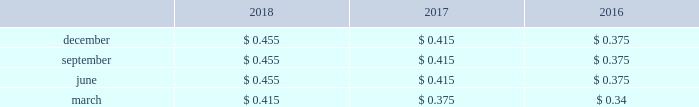Flows of the company 2019s subsidiaries , the receipt of dividends and repayments of indebtedness from the company 2019s subsidiaries , compliance with delaware corporate and other laws , compliance with the contractual provisions of debt and other agreements , and other factors .
The company 2019s dividend rate on its common stock is determined by the board of directors on a quarterly basis and takes into consideration , among other factors , current and possible future developments that may affect the company 2019s income and cash flows .
When dividends on common stock are declared , they are typically paid in march , june , september and december .
Historically , dividends have been paid quarterly to holders of record less than 30 days prior to the distribution date .
Since the dividends on the company 2019s common stock are not cumulative , only declared dividends are paid .
During 2018 , 2017 and 2016 , the company paid $ 319 million , $ 289 million and $ 261 million in cash dividends , respectively .
The table provides the per share cash dividends paid for the years ended december 31: .
On december 7 , 2018 , the company 2019s board of directors declared a quarterly cash dividend payment of $ 0.455 per share payable on march 1 , 2019 , to shareholders of record as of february 7 , 2019 .
Equity forward transaction see note 4 2014acquisitions and divestitures for information regarding the forward sale agreements entered into by the company on april 11 , 2018 , and the subsequent settlement of these agreements on june 7 , 2018 .
Regulatory restrictions the issuance of long-term debt or equity securities by the company or american water capital corp .
( 201cawcc 201d ) , the company 2019s wholly owned financing subsidiary , does not require authorization of any state puc if no guarantee or pledge of the regulated subsidiaries is utilized .
However , state puc authorization is required to issue long-term debt at most of the company 2019s regulated subsidiaries .
The company 2019s regulated subsidiaries normally obtain the required approvals on a periodic basis to cover their anticipated financing needs for a period of time or in connection with a specific financing .
Under applicable law , the company 2019s subsidiaries can pay dividends only from retained , undistributed or current earnings .
A significant loss recorded at a subsidiary may limit the dividends that the subsidiary can distribute to american water .
Furthermore , the ability of the company 2019s subsidiaries to pay upstream dividends or repay indebtedness to american water is subject to compliance with applicable regulatory restrictions and financial obligations , including , for example , debt service and preferred and preference stock dividends , as well as applicable corporate , tax and other laws and regulations , and other agreements or covenants made or entered into by the company and its subsidiaries .
Note 10 : stock based compensation the company has granted stock options , stock units and dividend equivalents to non-employee directors , officers and other key employees of the company pursuant to the terms of its 2007 omnibus equity compensation plan ( the 201c2007 plan 201d ) .
Stock units under the 2007 plan generally vest based on ( i ) continued employment with the company ( 201crsus 201d ) , or ( ii ) continued employment with the company where distribution of the shares is subject to the satisfaction in whole or in part of stated performance-based goals ( 201cpsus 201d ) .
The total aggregate number of shares of common stock that may be issued under the 2007 plan is 15.5 million .
As of .
In the fourth quarter of 2018 vs . 2017 , what was the increase in the cash dividend per share? 
Computations: (0.455 - 0.415)
Answer: 0.04. 